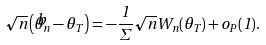<formula> <loc_0><loc_0><loc_500><loc_500>\sqrt { n } \left ( \widehat { \theta } _ { n } - \theta _ { T } \right ) = - \frac { 1 } { \Sigma } \sqrt { n } W _ { n } ( \theta _ { T } ) + o _ { P } ( 1 ) .</formula> 